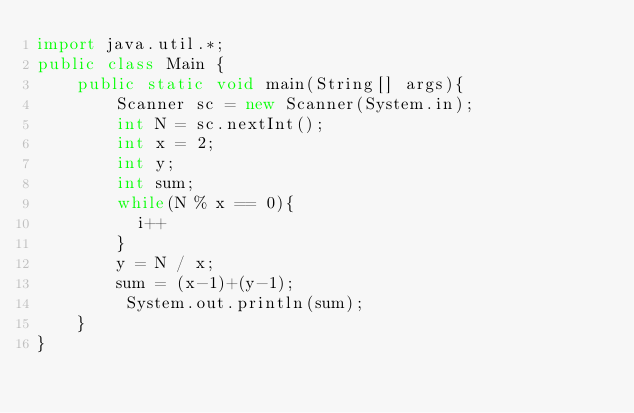Convert code to text. <code><loc_0><loc_0><loc_500><loc_500><_Java_>import java.util.*;
public class Main {
	public static void main(String[] args){
		Scanner sc = new Scanner(System.in);
        int N = sc.nextInt();
      	int x = 2;
        int y;
        int sum;
        while(N % x == 0){
          i++
        }
      	y = N / x;
        sum = (x-1)+(y-1);
		 System.out.println(sum);            
    }
}</code> 